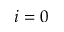Convert formula to latex. <formula><loc_0><loc_0><loc_500><loc_500>i = 0</formula> 